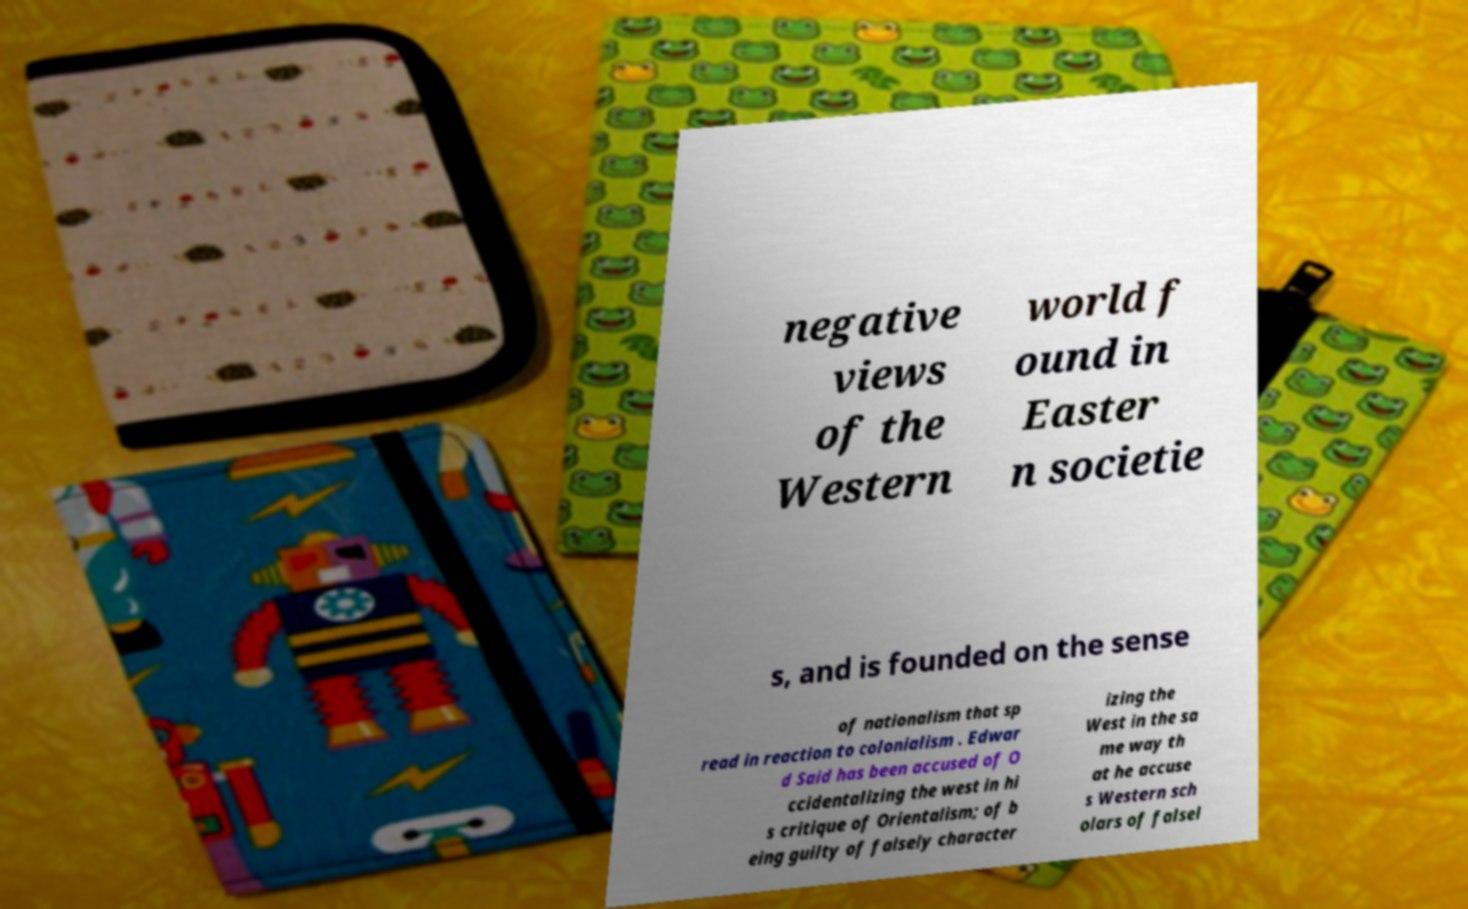There's text embedded in this image that I need extracted. Can you transcribe it verbatim? negative views of the Western world f ound in Easter n societie s, and is founded on the sense of nationalism that sp read in reaction to colonialism . Edwar d Said has been accused of O ccidentalizing the west in hi s critique of Orientalism; of b eing guilty of falsely character izing the West in the sa me way th at he accuse s Western sch olars of falsel 